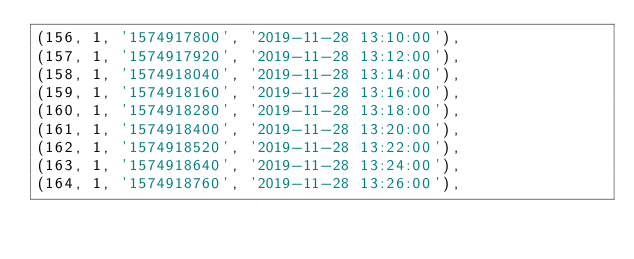Convert code to text. <code><loc_0><loc_0><loc_500><loc_500><_SQL_>(156, 1, '1574917800', '2019-11-28 13:10:00'),
(157, 1, '1574917920', '2019-11-28 13:12:00'),
(158, 1, '1574918040', '2019-11-28 13:14:00'),
(159, 1, '1574918160', '2019-11-28 13:16:00'),
(160, 1, '1574918280', '2019-11-28 13:18:00'),
(161, 1, '1574918400', '2019-11-28 13:20:00'),
(162, 1, '1574918520', '2019-11-28 13:22:00'),
(163, 1, '1574918640', '2019-11-28 13:24:00'),
(164, 1, '1574918760', '2019-11-28 13:26:00'),</code> 